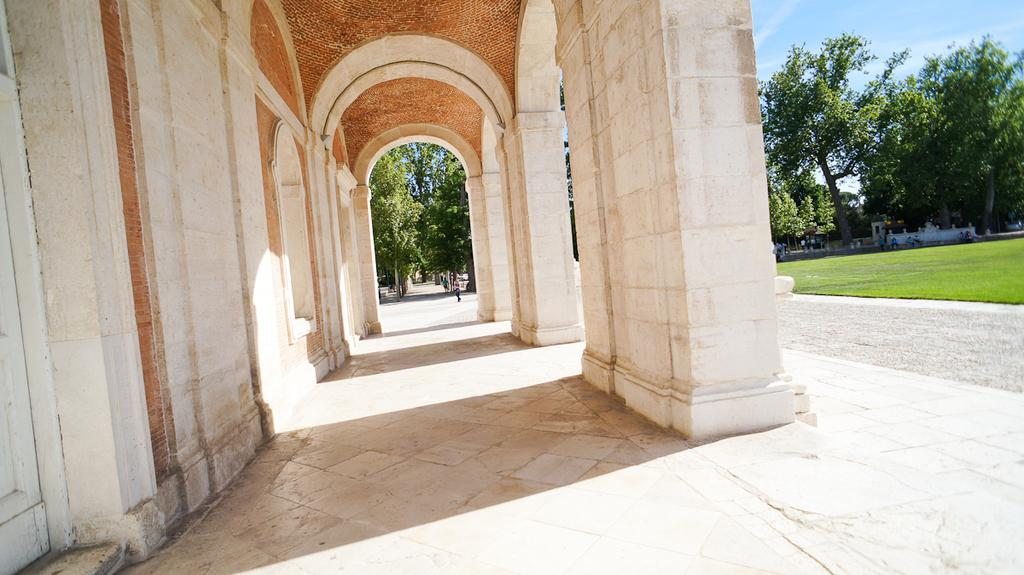How many people are in the image? There is a group of people in the image, but the exact number cannot be determined from the provided facts. What type of natural environment is visible in the image? There is grass and trees visible in the image, suggesting a natural setting. What type of structure can be seen in the image? There appears to be a building in the image. What is visible in the background of the image? The sky is visible in the background of the image. What type of instrument is the hen playing in the image? There is no hen or instrument present in the image. Can you tell me how many frogs are visible in the image? There are no frogs visible in the image. 